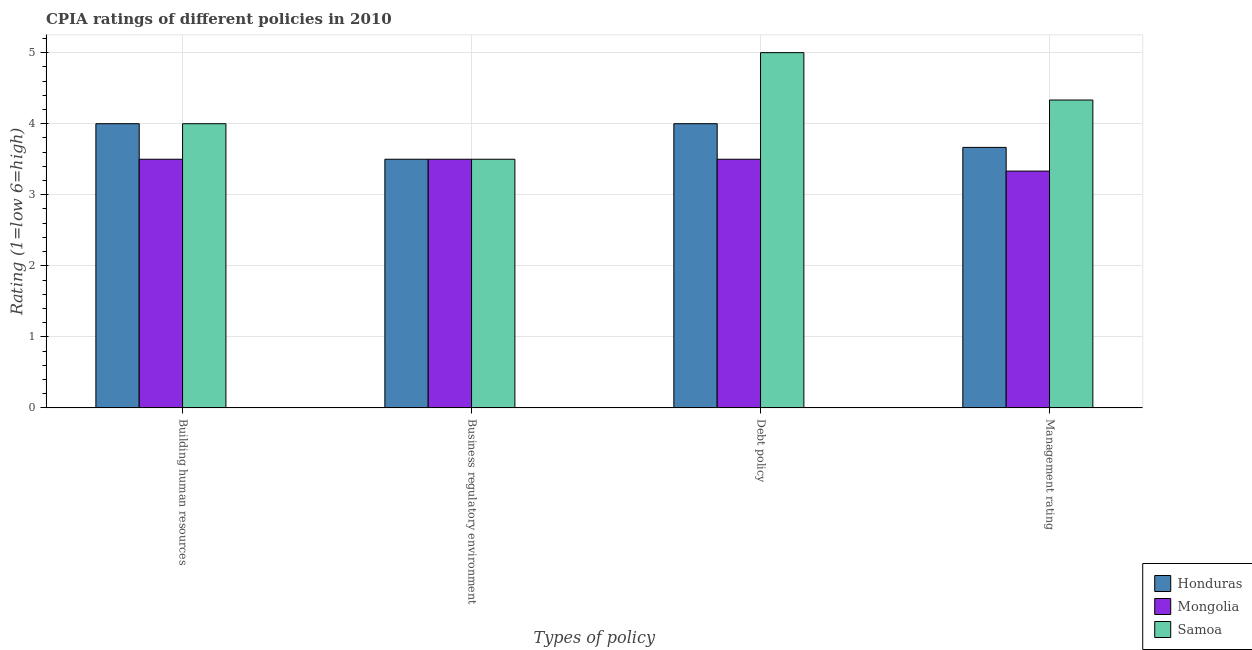How many different coloured bars are there?
Your answer should be compact. 3. Are the number of bars per tick equal to the number of legend labels?
Ensure brevity in your answer.  Yes. How many bars are there on the 2nd tick from the right?
Offer a very short reply. 3. What is the label of the 3rd group of bars from the left?
Your answer should be very brief. Debt policy. What is the cpia rating of management in Samoa?
Keep it short and to the point. 4.33. Across all countries, what is the maximum cpia rating of debt policy?
Keep it short and to the point. 5. In which country was the cpia rating of building human resources maximum?
Ensure brevity in your answer.  Honduras. In which country was the cpia rating of building human resources minimum?
Keep it short and to the point. Mongolia. What is the difference between the cpia rating of management in Mongolia and that in Honduras?
Your answer should be compact. -0.33. What is the difference between the cpia rating of management in Samoa and the cpia rating of debt policy in Honduras?
Your answer should be compact. 0.33. What is the ratio of the cpia rating of building human resources in Honduras to that in Mongolia?
Make the answer very short. 1.14. Is the cpia rating of debt policy in Mongolia less than that in Samoa?
Offer a terse response. Yes. What is the difference between the highest and the lowest cpia rating of building human resources?
Your response must be concise. 0.5. Is the sum of the cpia rating of building human resources in Mongolia and Honduras greater than the maximum cpia rating of management across all countries?
Your answer should be compact. Yes. What does the 3rd bar from the left in Debt policy represents?
Provide a succinct answer. Samoa. What does the 3rd bar from the right in Business regulatory environment represents?
Your response must be concise. Honduras. Is it the case that in every country, the sum of the cpia rating of building human resources and cpia rating of business regulatory environment is greater than the cpia rating of debt policy?
Your answer should be compact. Yes. Are the values on the major ticks of Y-axis written in scientific E-notation?
Keep it short and to the point. No. Does the graph contain any zero values?
Your response must be concise. No. Does the graph contain grids?
Your answer should be very brief. Yes. Where does the legend appear in the graph?
Provide a short and direct response. Bottom right. How many legend labels are there?
Give a very brief answer. 3. What is the title of the graph?
Your answer should be very brief. CPIA ratings of different policies in 2010. Does "Central Europe" appear as one of the legend labels in the graph?
Keep it short and to the point. No. What is the label or title of the X-axis?
Your answer should be compact. Types of policy. What is the Rating (1=low 6=high) of Honduras in Building human resources?
Your answer should be very brief. 4. What is the Rating (1=low 6=high) of Mongolia in Building human resources?
Ensure brevity in your answer.  3.5. What is the Rating (1=low 6=high) of Samoa in Building human resources?
Keep it short and to the point. 4. What is the Rating (1=low 6=high) in Samoa in Business regulatory environment?
Provide a short and direct response. 3.5. What is the Rating (1=low 6=high) of Mongolia in Debt policy?
Give a very brief answer. 3.5. What is the Rating (1=low 6=high) of Honduras in Management rating?
Provide a succinct answer. 3.67. What is the Rating (1=low 6=high) of Mongolia in Management rating?
Ensure brevity in your answer.  3.33. What is the Rating (1=low 6=high) in Samoa in Management rating?
Give a very brief answer. 4.33. Across all Types of policy, what is the maximum Rating (1=low 6=high) in Honduras?
Offer a very short reply. 4. Across all Types of policy, what is the maximum Rating (1=low 6=high) of Mongolia?
Your answer should be very brief. 3.5. Across all Types of policy, what is the minimum Rating (1=low 6=high) of Honduras?
Make the answer very short. 3.5. Across all Types of policy, what is the minimum Rating (1=low 6=high) in Mongolia?
Keep it short and to the point. 3.33. Across all Types of policy, what is the minimum Rating (1=low 6=high) in Samoa?
Keep it short and to the point. 3.5. What is the total Rating (1=low 6=high) in Honduras in the graph?
Offer a terse response. 15.17. What is the total Rating (1=low 6=high) of Mongolia in the graph?
Keep it short and to the point. 13.83. What is the total Rating (1=low 6=high) in Samoa in the graph?
Offer a very short reply. 16.83. What is the difference between the Rating (1=low 6=high) of Honduras in Building human resources and that in Business regulatory environment?
Keep it short and to the point. 0.5. What is the difference between the Rating (1=low 6=high) in Samoa in Building human resources and that in Business regulatory environment?
Provide a short and direct response. 0.5. What is the difference between the Rating (1=low 6=high) of Mongolia in Building human resources and that in Debt policy?
Your answer should be very brief. 0. What is the difference between the Rating (1=low 6=high) of Samoa in Building human resources and that in Debt policy?
Give a very brief answer. -1. What is the difference between the Rating (1=low 6=high) of Mongolia in Building human resources and that in Management rating?
Keep it short and to the point. 0.17. What is the difference between the Rating (1=low 6=high) in Samoa in Building human resources and that in Management rating?
Provide a succinct answer. -0.33. What is the difference between the Rating (1=low 6=high) in Honduras in Business regulatory environment and that in Debt policy?
Your answer should be compact. -0.5. What is the difference between the Rating (1=low 6=high) in Honduras in Debt policy and that in Management rating?
Ensure brevity in your answer.  0.33. What is the difference between the Rating (1=low 6=high) of Honduras in Building human resources and the Rating (1=low 6=high) of Mongolia in Business regulatory environment?
Offer a terse response. 0.5. What is the difference between the Rating (1=low 6=high) of Mongolia in Building human resources and the Rating (1=low 6=high) of Samoa in Business regulatory environment?
Ensure brevity in your answer.  0. What is the difference between the Rating (1=low 6=high) in Honduras in Building human resources and the Rating (1=low 6=high) in Mongolia in Debt policy?
Give a very brief answer. 0.5. What is the difference between the Rating (1=low 6=high) of Honduras in Building human resources and the Rating (1=low 6=high) of Samoa in Debt policy?
Your answer should be compact. -1. What is the difference between the Rating (1=low 6=high) in Honduras in Building human resources and the Rating (1=low 6=high) in Samoa in Management rating?
Your answer should be very brief. -0.33. What is the difference between the Rating (1=low 6=high) in Mongolia in Building human resources and the Rating (1=low 6=high) in Samoa in Management rating?
Your answer should be compact. -0.83. What is the difference between the Rating (1=low 6=high) of Honduras in Business regulatory environment and the Rating (1=low 6=high) of Mongolia in Debt policy?
Offer a terse response. 0. What is the difference between the Rating (1=low 6=high) of Honduras in Business regulatory environment and the Rating (1=low 6=high) of Samoa in Debt policy?
Offer a very short reply. -1.5. What is the difference between the Rating (1=low 6=high) of Honduras in Business regulatory environment and the Rating (1=low 6=high) of Samoa in Management rating?
Offer a very short reply. -0.83. What is the difference between the Rating (1=low 6=high) in Mongolia in Business regulatory environment and the Rating (1=low 6=high) in Samoa in Management rating?
Ensure brevity in your answer.  -0.83. What is the difference between the Rating (1=low 6=high) of Honduras in Debt policy and the Rating (1=low 6=high) of Mongolia in Management rating?
Keep it short and to the point. 0.67. What is the difference between the Rating (1=low 6=high) of Mongolia in Debt policy and the Rating (1=low 6=high) of Samoa in Management rating?
Keep it short and to the point. -0.83. What is the average Rating (1=low 6=high) in Honduras per Types of policy?
Your answer should be very brief. 3.79. What is the average Rating (1=low 6=high) of Mongolia per Types of policy?
Give a very brief answer. 3.46. What is the average Rating (1=low 6=high) of Samoa per Types of policy?
Keep it short and to the point. 4.21. What is the difference between the Rating (1=low 6=high) in Honduras and Rating (1=low 6=high) in Mongolia in Building human resources?
Provide a short and direct response. 0.5. What is the difference between the Rating (1=low 6=high) in Mongolia and Rating (1=low 6=high) in Samoa in Building human resources?
Offer a terse response. -0.5. What is the difference between the Rating (1=low 6=high) of Honduras and Rating (1=low 6=high) of Mongolia in Business regulatory environment?
Keep it short and to the point. 0. What is the difference between the Rating (1=low 6=high) of Honduras and Rating (1=low 6=high) of Samoa in Business regulatory environment?
Give a very brief answer. 0. What is the difference between the Rating (1=low 6=high) in Mongolia and Rating (1=low 6=high) in Samoa in Business regulatory environment?
Offer a very short reply. 0. What is the difference between the Rating (1=low 6=high) of Honduras and Rating (1=low 6=high) of Mongolia in Debt policy?
Provide a succinct answer. 0.5. What is the ratio of the Rating (1=low 6=high) in Mongolia in Building human resources to that in Debt policy?
Offer a terse response. 1. What is the ratio of the Rating (1=low 6=high) in Honduras in Building human resources to that in Management rating?
Offer a terse response. 1.09. What is the ratio of the Rating (1=low 6=high) in Mongolia in Business regulatory environment to that in Debt policy?
Offer a very short reply. 1. What is the ratio of the Rating (1=low 6=high) in Samoa in Business regulatory environment to that in Debt policy?
Your response must be concise. 0.7. What is the ratio of the Rating (1=low 6=high) of Honduras in Business regulatory environment to that in Management rating?
Your answer should be compact. 0.95. What is the ratio of the Rating (1=low 6=high) of Samoa in Business regulatory environment to that in Management rating?
Your answer should be compact. 0.81. What is the ratio of the Rating (1=low 6=high) of Samoa in Debt policy to that in Management rating?
Provide a short and direct response. 1.15. What is the difference between the highest and the lowest Rating (1=low 6=high) of Samoa?
Ensure brevity in your answer.  1.5. 